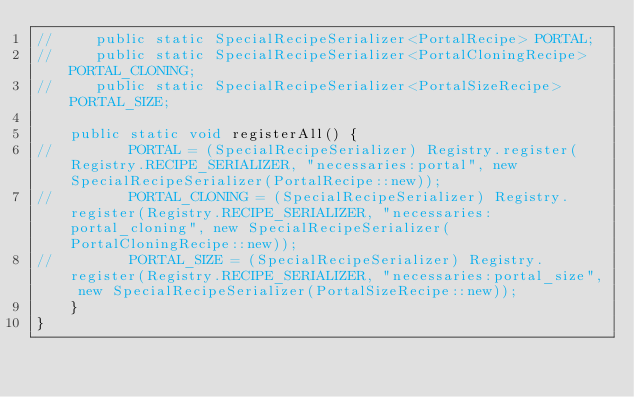<code> <loc_0><loc_0><loc_500><loc_500><_Java_>//     public static SpecialRecipeSerializer<PortalRecipe> PORTAL;
//     public static SpecialRecipeSerializer<PortalCloningRecipe> PORTAL_CLONING;
//     public static SpecialRecipeSerializer<PortalSizeRecipe> PORTAL_SIZE;

    public static void registerAll() {
//         PORTAL = (SpecialRecipeSerializer) Registry.register(Registry.RECIPE_SERIALIZER, "necessaries:portal", new SpecialRecipeSerializer(PortalRecipe::new));
//         PORTAL_CLONING = (SpecialRecipeSerializer) Registry.register(Registry.RECIPE_SERIALIZER, "necessaries:portal_cloning", new SpecialRecipeSerializer(PortalCloningRecipe::new));
//         PORTAL_SIZE = (SpecialRecipeSerializer) Registry.register(Registry.RECIPE_SERIALIZER, "necessaries:portal_size", new SpecialRecipeSerializer(PortalSizeRecipe::new));
    }
}
</code> 